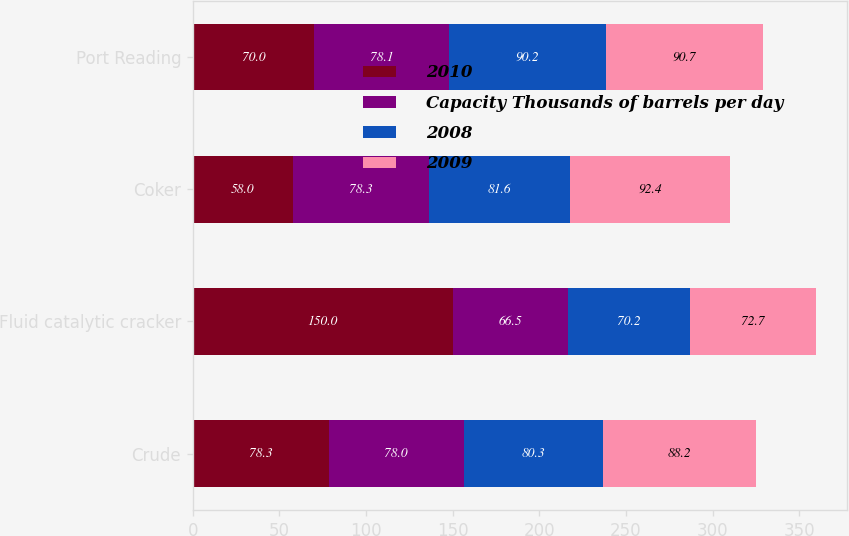Convert chart. <chart><loc_0><loc_0><loc_500><loc_500><stacked_bar_chart><ecel><fcel>Crude<fcel>Fluid catalytic cracker<fcel>Coker<fcel>Port Reading<nl><fcel>2010<fcel>78.3<fcel>150<fcel>58<fcel>70<nl><fcel>Capacity Thousands of barrels per day<fcel>78<fcel>66.5<fcel>78.3<fcel>78.1<nl><fcel>2008<fcel>80.3<fcel>70.2<fcel>81.6<fcel>90.2<nl><fcel>2009<fcel>88.2<fcel>72.7<fcel>92.4<fcel>90.7<nl></chart> 